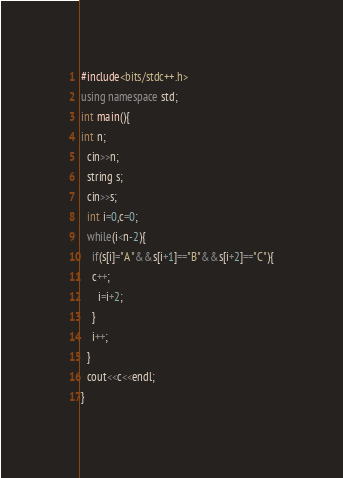Convert code to text. <code><loc_0><loc_0><loc_500><loc_500><_C++_>#include<bits/stdc++.h>
using namespace std;
int main(){
int n;
  cin>>n;
  string s;
  cin>>s;
  int i=0,c=0;
  while(i<n-2){
  	if(s[i]="A"&&s[i+1]=="B"&&s[i+2]=="C"){
    c++;
      i=i+2;
    }
    i++;
  }
  cout<<c<<endl;
}</code> 